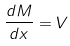<formula> <loc_0><loc_0><loc_500><loc_500>\frac { d M } { d x } = V</formula> 